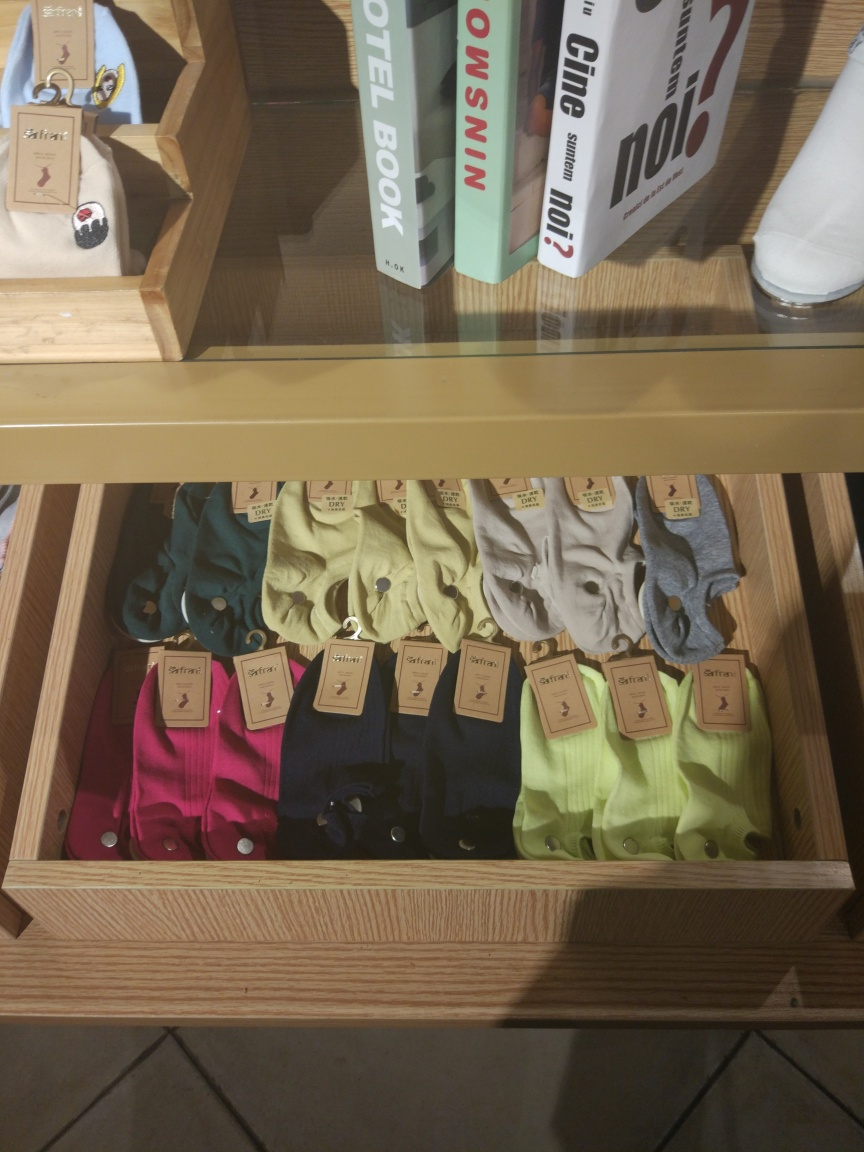Is the overall clarity of the image good? The clarity of the image is quite good as the details are reasonably sharp and colors are well defined, making the items on display easily distinguishable. One can clearly see the colorful assortment of polos neatly arranged in the wooden shelf, along with some books to the side, suggesting a retail environment likely focused on lifestyle or fashion products. 